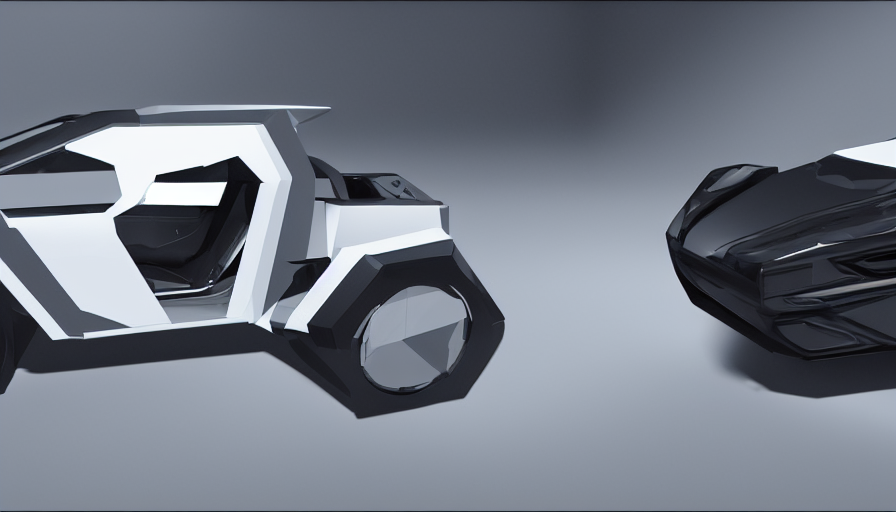How does the composition of the image influence the perception of the objects? This image's composition plays a crucial role in our perception of the objects. The use of space and positioning conveys a sense of balance and symmetry, while the perspective from which we view the objects highlights their geometric forms and adds a dynamic quality. The objects are placed in such a way that they seem to be interacting with each other, perhaps ready to engage in motion, hinting at functionality and purpose within their narrative context. 